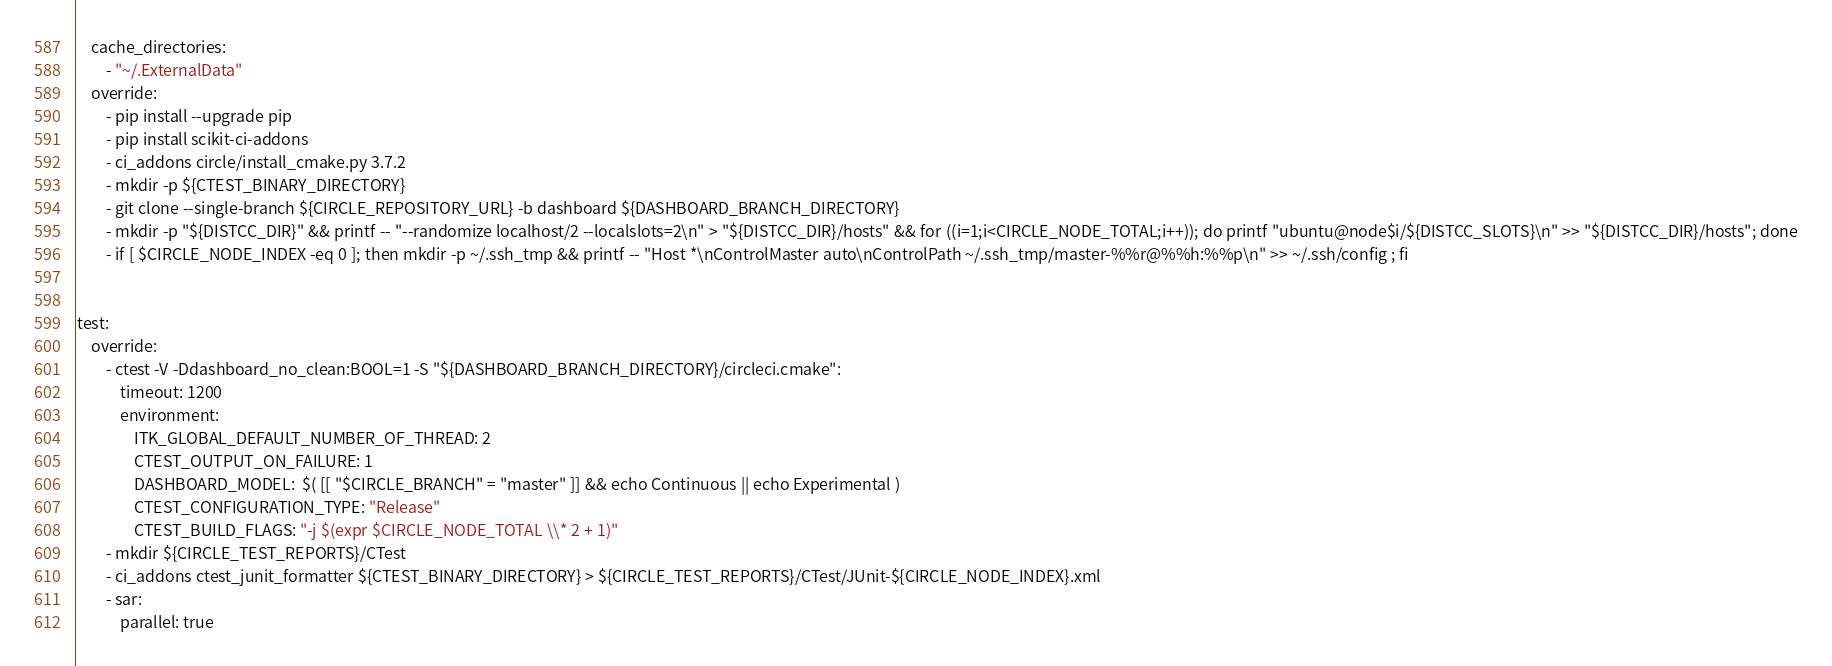Convert code to text. <code><loc_0><loc_0><loc_500><loc_500><_YAML_>    cache_directories:
        - "~/.ExternalData"
    override:
        - pip install --upgrade pip
        - pip install scikit-ci-addons
        - ci_addons circle/install_cmake.py 3.7.2
        - mkdir -p ${CTEST_BINARY_DIRECTORY}
        - git clone --single-branch ${CIRCLE_REPOSITORY_URL} -b dashboard ${DASHBOARD_BRANCH_DIRECTORY}
        - mkdir -p "${DISTCC_DIR}" && printf -- "--randomize localhost/2 --localslots=2\n" > "${DISTCC_DIR}/hosts" && for ((i=1;i<CIRCLE_NODE_TOTAL;i++)); do printf "ubuntu@node$i/${DISTCC_SLOTS}\n" >> "${DISTCC_DIR}/hosts"; done
        - if [ $CIRCLE_NODE_INDEX -eq 0 ]; then mkdir -p ~/.ssh_tmp && printf -- "Host *\nControlMaster auto\nControlPath ~/.ssh_tmp/master-%%r@%%h:%%p\n" >> ~/.ssh/config ; fi


test:
    override:
        - ctest -V -Ddashboard_no_clean:BOOL=1 -S "${DASHBOARD_BRANCH_DIRECTORY}/circleci.cmake":
            timeout: 1200
            environment:
                ITK_GLOBAL_DEFAULT_NUMBER_OF_THREAD: 2
                CTEST_OUTPUT_ON_FAILURE: 1
                DASHBOARD_MODEL:  $( [[ "$CIRCLE_BRANCH" = "master" ]] && echo Continuous || echo Experimental )
                CTEST_CONFIGURATION_TYPE: "Release"
                CTEST_BUILD_FLAGS: "-j $(expr $CIRCLE_NODE_TOTAL \\* 2 + 1)"
        - mkdir ${CIRCLE_TEST_REPORTS}/CTest
        - ci_addons ctest_junit_formatter ${CTEST_BINARY_DIRECTORY} > ${CIRCLE_TEST_REPORTS}/CTest/JUnit-${CIRCLE_NODE_INDEX}.xml
        - sar:
            parallel: true
</code> 